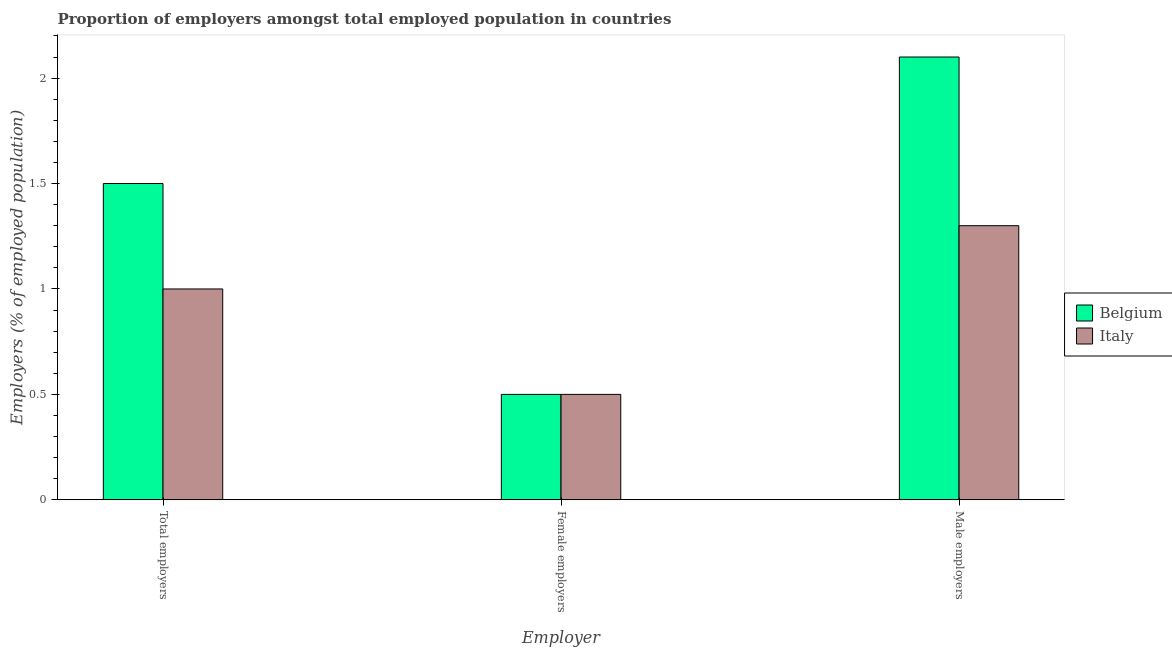How many different coloured bars are there?
Provide a succinct answer. 2. How many groups of bars are there?
Keep it short and to the point. 3. Are the number of bars per tick equal to the number of legend labels?
Your answer should be very brief. Yes. How many bars are there on the 1st tick from the right?
Make the answer very short. 2. What is the label of the 3rd group of bars from the left?
Your answer should be very brief. Male employers. Across all countries, what is the maximum percentage of male employers?
Provide a short and direct response. 2.1. In which country was the percentage of female employers minimum?
Make the answer very short. Belgium. What is the total percentage of male employers in the graph?
Keep it short and to the point. 3.4. What is the difference between the percentage of male employers in Belgium and that in Italy?
Your response must be concise. 0.8. What is the difference between the percentage of male employers in Belgium and the percentage of total employers in Italy?
Your response must be concise. 1.1. What is the average percentage of male employers per country?
Keep it short and to the point. 1.7. What is the difference between the percentage of female employers and percentage of male employers in Belgium?
Keep it short and to the point. -1.6. In how many countries, is the percentage of total employers greater than 1.7 %?
Your response must be concise. 0. What is the ratio of the percentage of male employers in Belgium to that in Italy?
Keep it short and to the point. 1.62. Is the percentage of female employers in Italy less than that in Belgium?
Ensure brevity in your answer.  No. Is the difference between the percentage of total employers in Italy and Belgium greater than the difference between the percentage of female employers in Italy and Belgium?
Provide a short and direct response. No. What is the difference between the highest and the lowest percentage of female employers?
Make the answer very short. 0. Is the sum of the percentage of male employers in Belgium and Italy greater than the maximum percentage of female employers across all countries?
Your answer should be very brief. Yes. What does the 1st bar from the right in Total employers represents?
Ensure brevity in your answer.  Italy. Are all the bars in the graph horizontal?
Make the answer very short. No. How many countries are there in the graph?
Your response must be concise. 2. What is the difference between two consecutive major ticks on the Y-axis?
Your answer should be very brief. 0.5. Where does the legend appear in the graph?
Ensure brevity in your answer.  Center right. How many legend labels are there?
Your response must be concise. 2. What is the title of the graph?
Provide a succinct answer. Proportion of employers amongst total employed population in countries. Does "Low & middle income" appear as one of the legend labels in the graph?
Provide a succinct answer. No. What is the label or title of the X-axis?
Ensure brevity in your answer.  Employer. What is the label or title of the Y-axis?
Offer a very short reply. Employers (% of employed population). What is the Employers (% of employed population) in Italy in Total employers?
Your response must be concise. 1. What is the Employers (% of employed population) of Belgium in Male employers?
Offer a terse response. 2.1. What is the Employers (% of employed population) in Italy in Male employers?
Make the answer very short. 1.3. Across all Employer, what is the maximum Employers (% of employed population) in Belgium?
Give a very brief answer. 2.1. Across all Employer, what is the maximum Employers (% of employed population) in Italy?
Provide a short and direct response. 1.3. Across all Employer, what is the minimum Employers (% of employed population) of Belgium?
Offer a very short reply. 0.5. What is the total Employers (% of employed population) of Belgium in the graph?
Ensure brevity in your answer.  4.1. What is the difference between the Employers (% of employed population) of Belgium in Female employers and that in Male employers?
Your answer should be compact. -1.6. What is the difference between the Employers (% of employed population) in Belgium in Total employers and the Employers (% of employed population) in Italy in Female employers?
Ensure brevity in your answer.  1. What is the difference between the Employers (% of employed population) in Belgium in Total employers and the Employers (% of employed population) in Italy in Male employers?
Provide a short and direct response. 0.2. What is the difference between the Employers (% of employed population) in Belgium in Female employers and the Employers (% of employed population) in Italy in Male employers?
Make the answer very short. -0.8. What is the average Employers (% of employed population) in Belgium per Employer?
Offer a very short reply. 1.37. What is the average Employers (% of employed population) of Italy per Employer?
Make the answer very short. 0.93. What is the difference between the Employers (% of employed population) of Belgium and Employers (% of employed population) of Italy in Total employers?
Make the answer very short. 0.5. What is the difference between the Employers (% of employed population) of Belgium and Employers (% of employed population) of Italy in Male employers?
Make the answer very short. 0.8. What is the ratio of the Employers (% of employed population) of Belgium in Total employers to that in Female employers?
Make the answer very short. 3. What is the ratio of the Employers (% of employed population) of Belgium in Total employers to that in Male employers?
Provide a short and direct response. 0.71. What is the ratio of the Employers (% of employed population) of Italy in Total employers to that in Male employers?
Your answer should be compact. 0.77. What is the ratio of the Employers (% of employed population) of Belgium in Female employers to that in Male employers?
Your answer should be very brief. 0.24. What is the ratio of the Employers (% of employed population) in Italy in Female employers to that in Male employers?
Make the answer very short. 0.38. What is the difference between the highest and the lowest Employers (% of employed population) in Belgium?
Offer a terse response. 1.6. 